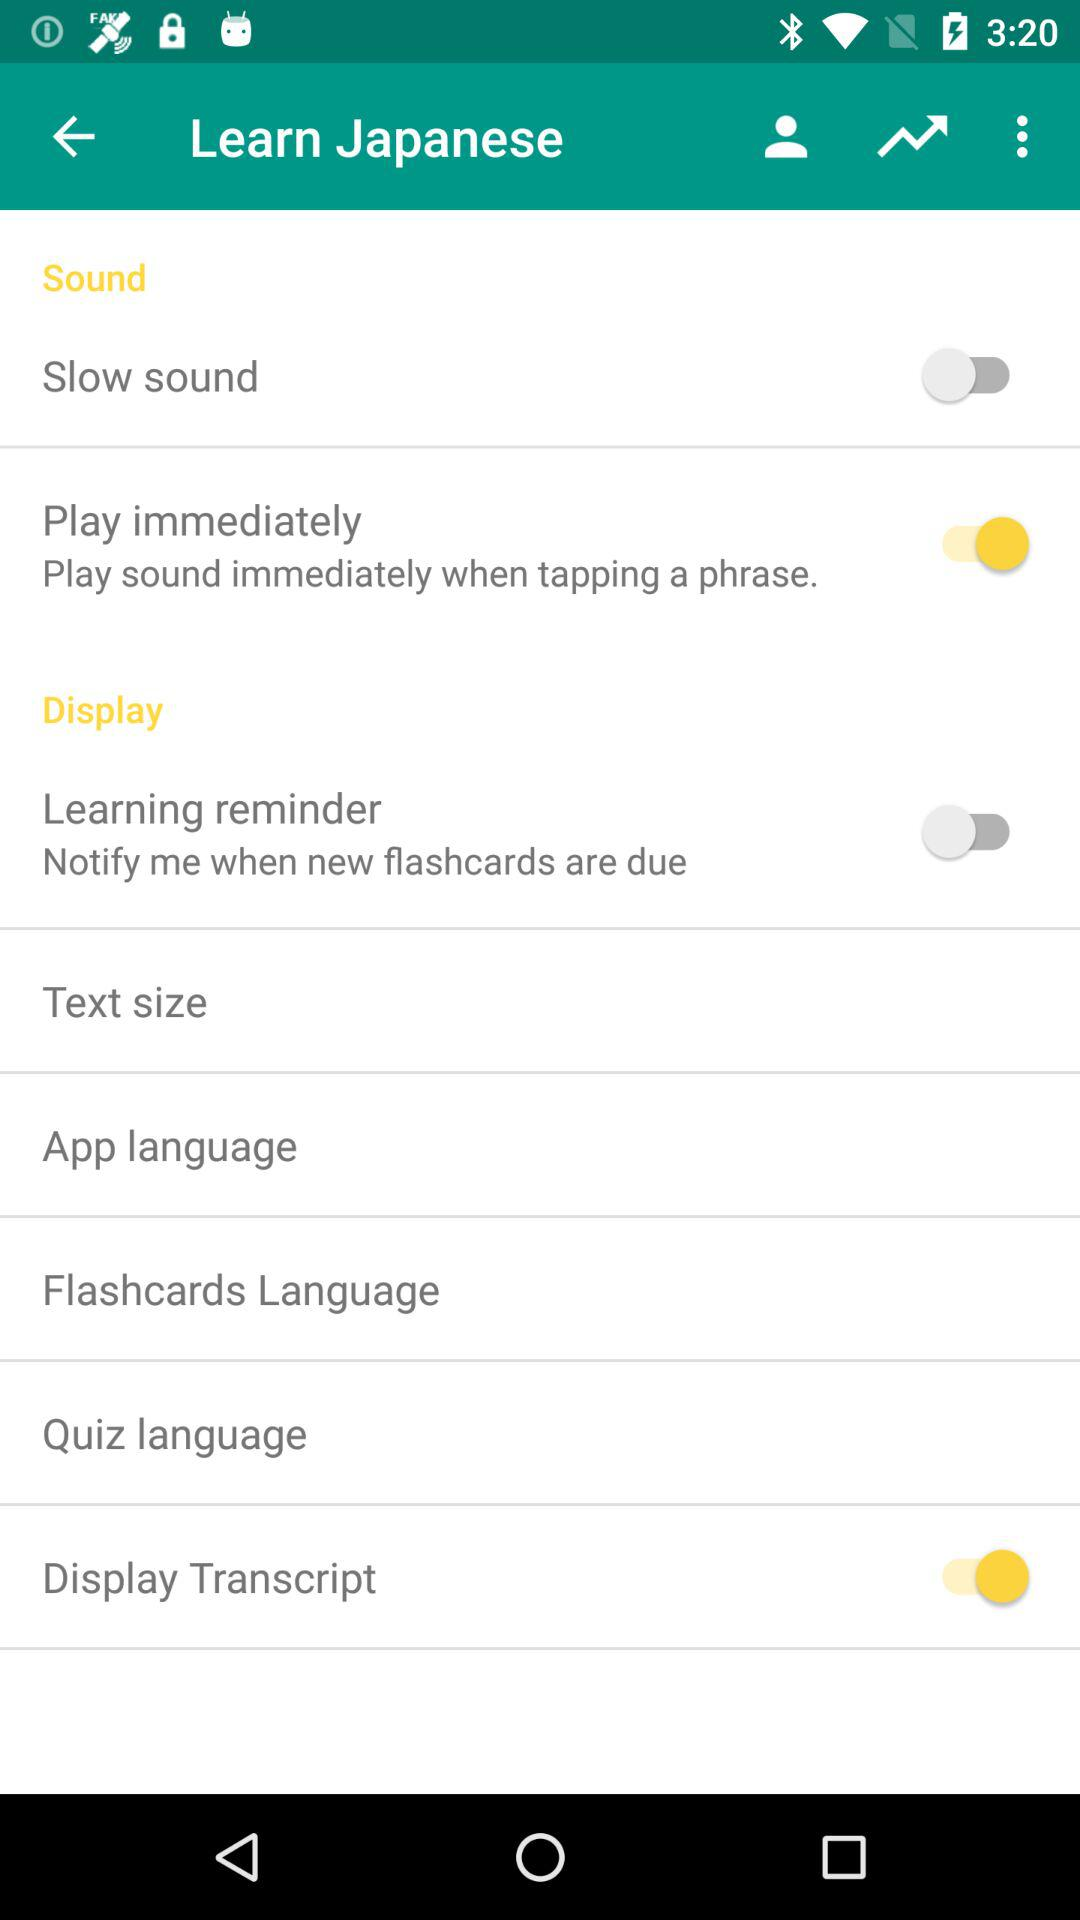What is the status of the "Learning reminder" setting? The 'Learning reminder' setting is currently turned off, as indicated by the toggle positioned to the left and colored grey, contrasting with active settings toggles which are colored yellow and positioned to the right. 